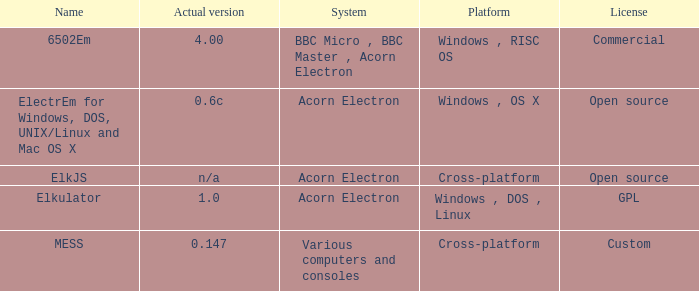Which system is named ELKJS? Acorn Electron. 